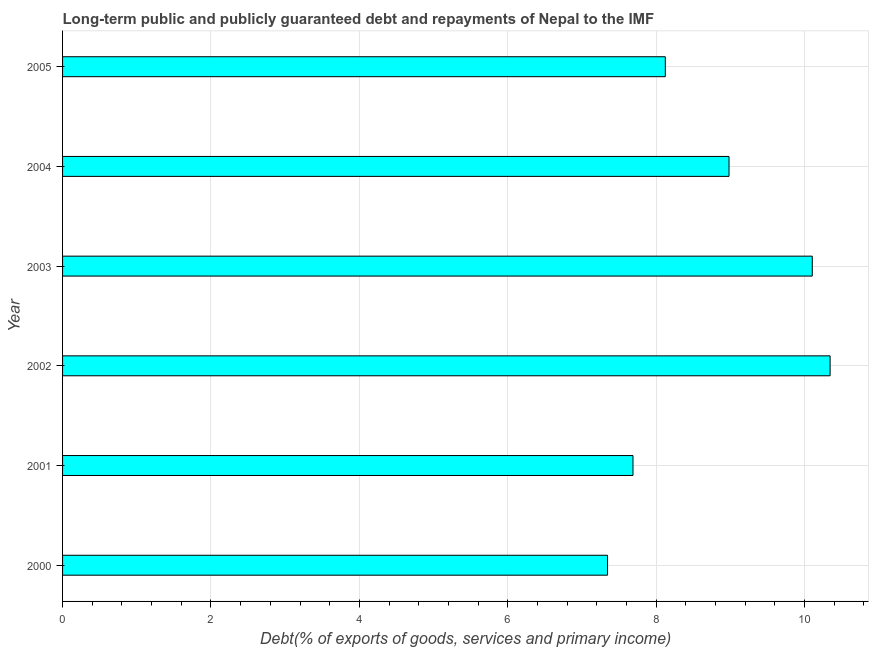Does the graph contain grids?
Your answer should be compact. Yes. What is the title of the graph?
Keep it short and to the point. Long-term public and publicly guaranteed debt and repayments of Nepal to the IMF. What is the label or title of the X-axis?
Offer a terse response. Debt(% of exports of goods, services and primary income). What is the debt service in 2005?
Your response must be concise. 8.12. Across all years, what is the maximum debt service?
Your response must be concise. 10.34. Across all years, what is the minimum debt service?
Offer a very short reply. 7.34. In which year was the debt service maximum?
Give a very brief answer. 2002. What is the sum of the debt service?
Your answer should be very brief. 52.58. What is the difference between the debt service in 2001 and 2004?
Offer a very short reply. -1.29. What is the average debt service per year?
Ensure brevity in your answer.  8.76. What is the median debt service?
Ensure brevity in your answer.  8.55. In how many years, is the debt service greater than 0.8 %?
Provide a short and direct response. 6. What is the ratio of the debt service in 2000 to that in 2003?
Offer a very short reply. 0.73. Is the difference between the debt service in 2004 and 2005 greater than the difference between any two years?
Give a very brief answer. No. What is the difference between the highest and the second highest debt service?
Provide a succinct answer. 0.24. Are all the bars in the graph horizontal?
Your answer should be very brief. Yes. How many years are there in the graph?
Offer a terse response. 6. Are the values on the major ticks of X-axis written in scientific E-notation?
Offer a terse response. No. What is the Debt(% of exports of goods, services and primary income) in 2000?
Your answer should be compact. 7.34. What is the Debt(% of exports of goods, services and primary income) in 2001?
Ensure brevity in your answer.  7.69. What is the Debt(% of exports of goods, services and primary income) in 2002?
Offer a very short reply. 10.34. What is the Debt(% of exports of goods, services and primary income) in 2003?
Provide a succinct answer. 10.1. What is the Debt(% of exports of goods, services and primary income) of 2004?
Your answer should be very brief. 8.98. What is the Debt(% of exports of goods, services and primary income) of 2005?
Make the answer very short. 8.12. What is the difference between the Debt(% of exports of goods, services and primary income) in 2000 and 2001?
Your response must be concise. -0.34. What is the difference between the Debt(% of exports of goods, services and primary income) in 2000 and 2002?
Your answer should be compact. -3. What is the difference between the Debt(% of exports of goods, services and primary income) in 2000 and 2003?
Your answer should be very brief. -2.76. What is the difference between the Debt(% of exports of goods, services and primary income) in 2000 and 2004?
Provide a short and direct response. -1.64. What is the difference between the Debt(% of exports of goods, services and primary income) in 2000 and 2005?
Give a very brief answer. -0.78. What is the difference between the Debt(% of exports of goods, services and primary income) in 2001 and 2002?
Make the answer very short. -2.66. What is the difference between the Debt(% of exports of goods, services and primary income) in 2001 and 2003?
Keep it short and to the point. -2.42. What is the difference between the Debt(% of exports of goods, services and primary income) in 2001 and 2004?
Offer a very short reply. -1.29. What is the difference between the Debt(% of exports of goods, services and primary income) in 2001 and 2005?
Give a very brief answer. -0.44. What is the difference between the Debt(% of exports of goods, services and primary income) in 2002 and 2003?
Your answer should be very brief. 0.24. What is the difference between the Debt(% of exports of goods, services and primary income) in 2002 and 2004?
Your answer should be very brief. 1.36. What is the difference between the Debt(% of exports of goods, services and primary income) in 2002 and 2005?
Provide a short and direct response. 2.22. What is the difference between the Debt(% of exports of goods, services and primary income) in 2003 and 2004?
Your answer should be compact. 1.12. What is the difference between the Debt(% of exports of goods, services and primary income) in 2003 and 2005?
Offer a terse response. 1.98. What is the difference between the Debt(% of exports of goods, services and primary income) in 2004 and 2005?
Offer a very short reply. 0.86. What is the ratio of the Debt(% of exports of goods, services and primary income) in 2000 to that in 2001?
Offer a very short reply. 0.95. What is the ratio of the Debt(% of exports of goods, services and primary income) in 2000 to that in 2002?
Keep it short and to the point. 0.71. What is the ratio of the Debt(% of exports of goods, services and primary income) in 2000 to that in 2003?
Your answer should be very brief. 0.73. What is the ratio of the Debt(% of exports of goods, services and primary income) in 2000 to that in 2004?
Offer a very short reply. 0.82. What is the ratio of the Debt(% of exports of goods, services and primary income) in 2000 to that in 2005?
Your answer should be very brief. 0.9. What is the ratio of the Debt(% of exports of goods, services and primary income) in 2001 to that in 2002?
Offer a very short reply. 0.74. What is the ratio of the Debt(% of exports of goods, services and primary income) in 2001 to that in 2003?
Make the answer very short. 0.76. What is the ratio of the Debt(% of exports of goods, services and primary income) in 2001 to that in 2004?
Provide a short and direct response. 0.86. What is the ratio of the Debt(% of exports of goods, services and primary income) in 2001 to that in 2005?
Offer a very short reply. 0.95. What is the ratio of the Debt(% of exports of goods, services and primary income) in 2002 to that in 2003?
Your answer should be compact. 1.02. What is the ratio of the Debt(% of exports of goods, services and primary income) in 2002 to that in 2004?
Your answer should be compact. 1.15. What is the ratio of the Debt(% of exports of goods, services and primary income) in 2002 to that in 2005?
Your answer should be compact. 1.27. What is the ratio of the Debt(% of exports of goods, services and primary income) in 2003 to that in 2004?
Your answer should be very brief. 1.12. What is the ratio of the Debt(% of exports of goods, services and primary income) in 2003 to that in 2005?
Make the answer very short. 1.24. What is the ratio of the Debt(% of exports of goods, services and primary income) in 2004 to that in 2005?
Provide a succinct answer. 1.11. 